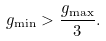<formula> <loc_0><loc_0><loc_500><loc_500>g _ { \min } > \frac { g _ { \max } } { 3 } .</formula> 